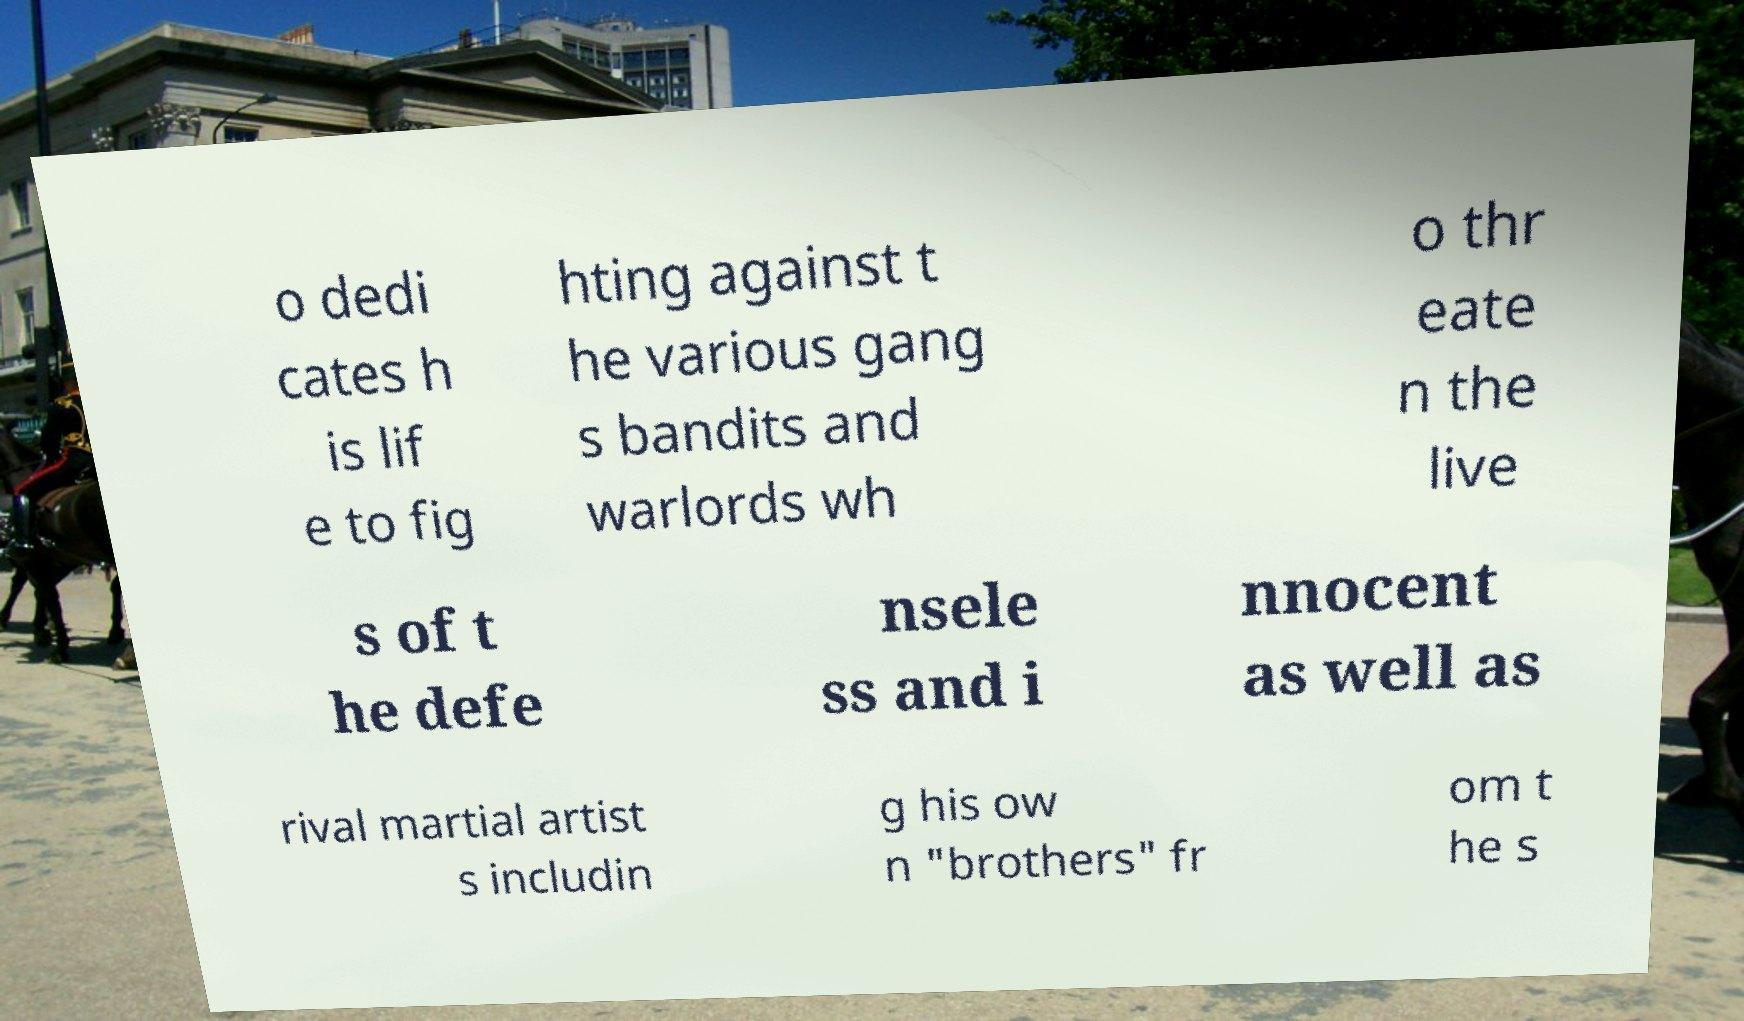Can you read and provide the text displayed in the image?This photo seems to have some interesting text. Can you extract and type it out for me? o dedi cates h is lif e to fig hting against t he various gang s bandits and warlords wh o thr eate n the live s of t he defe nsele ss and i nnocent as well as rival martial artist s includin g his ow n "brothers" fr om t he s 